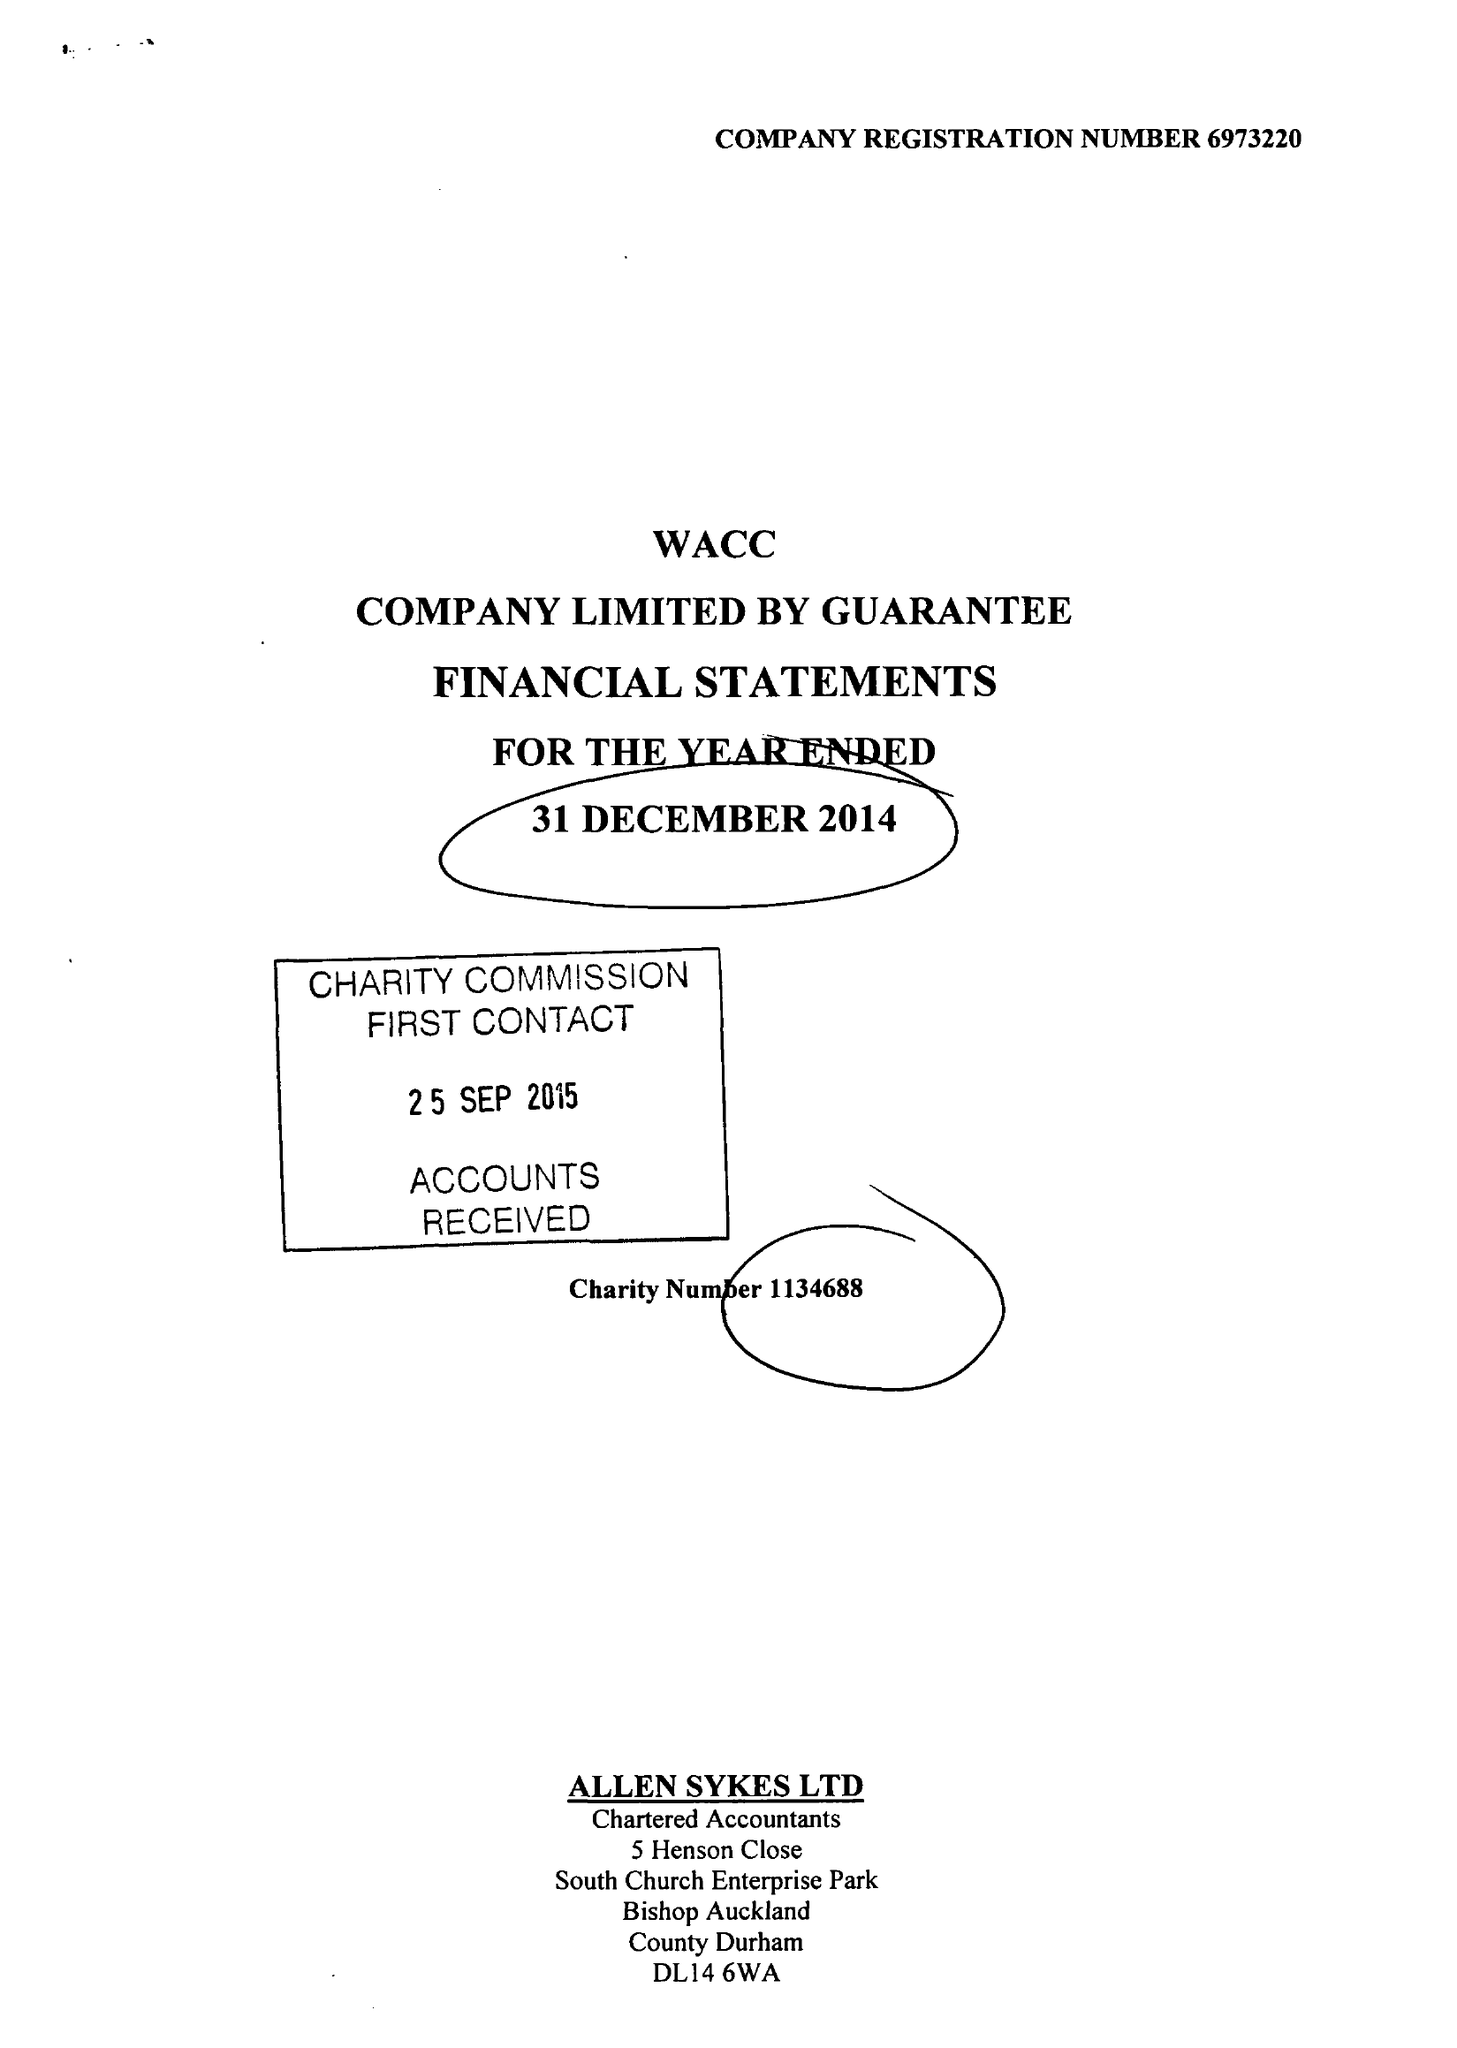What is the value for the charity_name?
Answer the question using a single word or phrase. West Auckland Community Church 